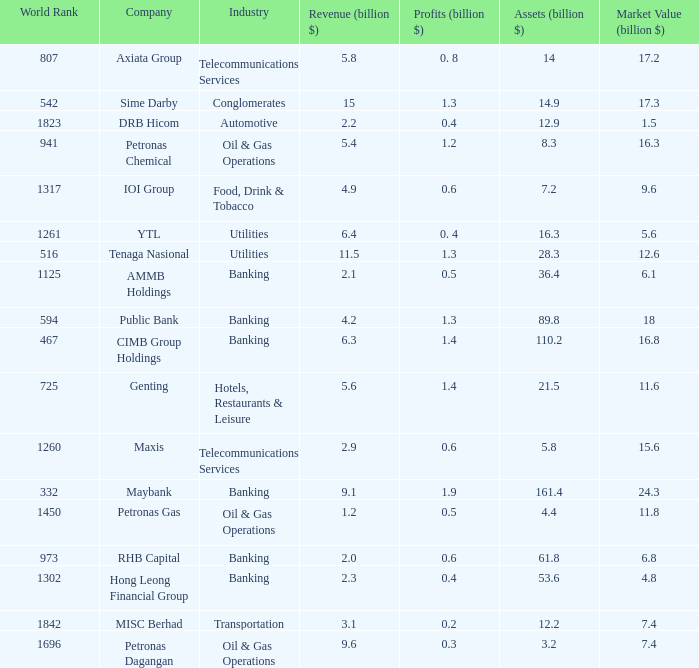Name the industry for revenue being 2.1 Banking. 